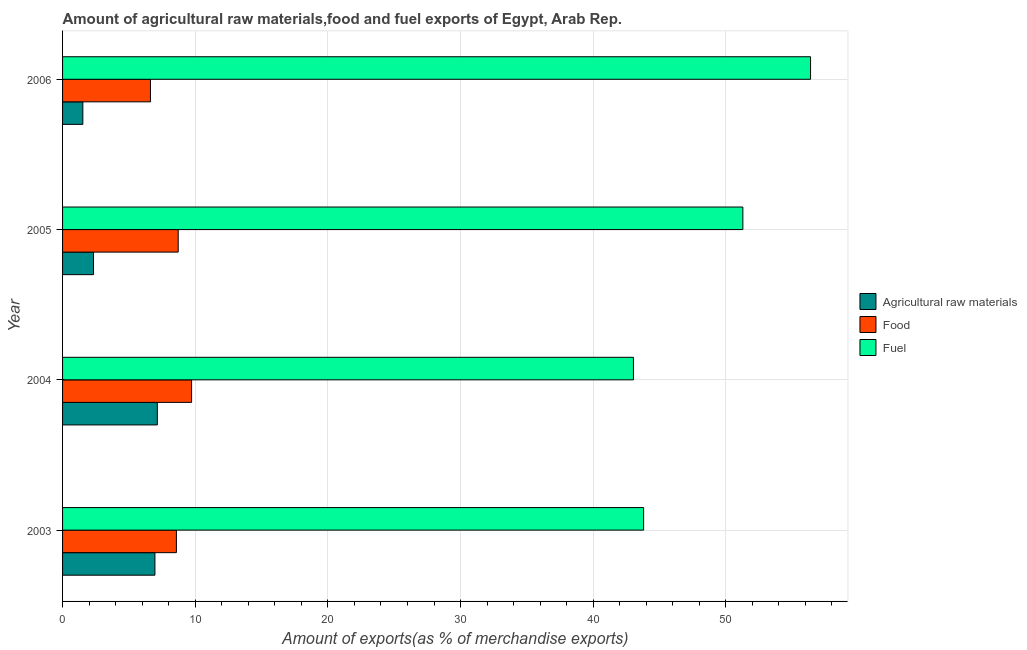How many different coloured bars are there?
Your answer should be compact. 3. Are the number of bars per tick equal to the number of legend labels?
Ensure brevity in your answer.  Yes. Are the number of bars on each tick of the Y-axis equal?
Give a very brief answer. Yes. What is the label of the 4th group of bars from the top?
Your answer should be very brief. 2003. What is the percentage of food exports in 2006?
Offer a very short reply. 6.63. Across all years, what is the maximum percentage of fuel exports?
Give a very brief answer. 56.39. Across all years, what is the minimum percentage of fuel exports?
Ensure brevity in your answer.  43.03. In which year was the percentage of raw materials exports maximum?
Keep it short and to the point. 2004. What is the total percentage of food exports in the graph?
Keep it short and to the point. 33.65. What is the difference between the percentage of fuel exports in 2004 and that in 2005?
Provide a short and direct response. -8.25. What is the difference between the percentage of food exports in 2004 and the percentage of fuel exports in 2005?
Your answer should be compact. -41.56. What is the average percentage of raw materials exports per year?
Your answer should be very brief. 4.49. In the year 2005, what is the difference between the percentage of raw materials exports and percentage of food exports?
Make the answer very short. -6.39. What is the ratio of the percentage of fuel exports in 2003 to that in 2005?
Provide a short and direct response. 0.85. Is the difference between the percentage of fuel exports in 2005 and 2006 greater than the difference between the percentage of food exports in 2005 and 2006?
Your answer should be compact. No. What is the difference between the highest and the second highest percentage of raw materials exports?
Give a very brief answer. 0.18. What is the difference between the highest and the lowest percentage of raw materials exports?
Give a very brief answer. 5.62. In how many years, is the percentage of fuel exports greater than the average percentage of fuel exports taken over all years?
Provide a short and direct response. 2. What does the 2nd bar from the top in 2005 represents?
Provide a succinct answer. Food. What does the 2nd bar from the bottom in 2006 represents?
Keep it short and to the point. Food. Is it the case that in every year, the sum of the percentage of raw materials exports and percentage of food exports is greater than the percentage of fuel exports?
Provide a short and direct response. No. How many bars are there?
Provide a short and direct response. 12. What is the difference between two consecutive major ticks on the X-axis?
Your response must be concise. 10. Where does the legend appear in the graph?
Offer a very short reply. Center right. How are the legend labels stacked?
Keep it short and to the point. Vertical. What is the title of the graph?
Offer a terse response. Amount of agricultural raw materials,food and fuel exports of Egypt, Arab Rep. Does "Male employers" appear as one of the legend labels in the graph?
Make the answer very short. No. What is the label or title of the X-axis?
Your response must be concise. Amount of exports(as % of merchandise exports). What is the label or title of the Y-axis?
Provide a short and direct response. Year. What is the Amount of exports(as % of merchandise exports) of Agricultural raw materials in 2003?
Provide a short and direct response. 6.96. What is the Amount of exports(as % of merchandise exports) in Food in 2003?
Offer a terse response. 8.58. What is the Amount of exports(as % of merchandise exports) in Fuel in 2003?
Offer a very short reply. 43.8. What is the Amount of exports(as % of merchandise exports) in Agricultural raw materials in 2004?
Provide a short and direct response. 7.14. What is the Amount of exports(as % of merchandise exports) of Food in 2004?
Your answer should be compact. 9.73. What is the Amount of exports(as % of merchandise exports) of Fuel in 2004?
Provide a succinct answer. 43.03. What is the Amount of exports(as % of merchandise exports) of Agricultural raw materials in 2005?
Provide a short and direct response. 2.33. What is the Amount of exports(as % of merchandise exports) of Food in 2005?
Ensure brevity in your answer.  8.72. What is the Amount of exports(as % of merchandise exports) in Fuel in 2005?
Ensure brevity in your answer.  51.28. What is the Amount of exports(as % of merchandise exports) in Agricultural raw materials in 2006?
Your answer should be very brief. 1.53. What is the Amount of exports(as % of merchandise exports) of Food in 2006?
Provide a succinct answer. 6.63. What is the Amount of exports(as % of merchandise exports) of Fuel in 2006?
Give a very brief answer. 56.39. Across all years, what is the maximum Amount of exports(as % of merchandise exports) in Agricultural raw materials?
Your answer should be very brief. 7.14. Across all years, what is the maximum Amount of exports(as % of merchandise exports) of Food?
Your answer should be very brief. 9.73. Across all years, what is the maximum Amount of exports(as % of merchandise exports) of Fuel?
Give a very brief answer. 56.39. Across all years, what is the minimum Amount of exports(as % of merchandise exports) of Agricultural raw materials?
Offer a very short reply. 1.53. Across all years, what is the minimum Amount of exports(as % of merchandise exports) in Food?
Make the answer very short. 6.63. Across all years, what is the minimum Amount of exports(as % of merchandise exports) of Fuel?
Give a very brief answer. 43.03. What is the total Amount of exports(as % of merchandise exports) of Agricultural raw materials in the graph?
Give a very brief answer. 17.97. What is the total Amount of exports(as % of merchandise exports) in Food in the graph?
Keep it short and to the point. 33.65. What is the total Amount of exports(as % of merchandise exports) of Fuel in the graph?
Provide a short and direct response. 194.51. What is the difference between the Amount of exports(as % of merchandise exports) in Agricultural raw materials in 2003 and that in 2004?
Offer a terse response. -0.18. What is the difference between the Amount of exports(as % of merchandise exports) of Food in 2003 and that in 2004?
Offer a very short reply. -1.14. What is the difference between the Amount of exports(as % of merchandise exports) of Fuel in 2003 and that in 2004?
Ensure brevity in your answer.  0.77. What is the difference between the Amount of exports(as % of merchandise exports) of Agricultural raw materials in 2003 and that in 2005?
Provide a succinct answer. 4.63. What is the difference between the Amount of exports(as % of merchandise exports) of Food in 2003 and that in 2005?
Your answer should be very brief. -0.14. What is the difference between the Amount of exports(as % of merchandise exports) of Fuel in 2003 and that in 2005?
Make the answer very short. -7.48. What is the difference between the Amount of exports(as % of merchandise exports) of Agricultural raw materials in 2003 and that in 2006?
Give a very brief answer. 5.43. What is the difference between the Amount of exports(as % of merchandise exports) of Food in 2003 and that in 2006?
Provide a succinct answer. 1.96. What is the difference between the Amount of exports(as % of merchandise exports) in Fuel in 2003 and that in 2006?
Offer a terse response. -12.58. What is the difference between the Amount of exports(as % of merchandise exports) in Agricultural raw materials in 2004 and that in 2005?
Offer a very short reply. 4.81. What is the difference between the Amount of exports(as % of merchandise exports) in Food in 2004 and that in 2005?
Provide a succinct answer. 1.01. What is the difference between the Amount of exports(as % of merchandise exports) of Fuel in 2004 and that in 2005?
Your response must be concise. -8.25. What is the difference between the Amount of exports(as % of merchandise exports) of Agricultural raw materials in 2004 and that in 2006?
Your answer should be very brief. 5.62. What is the difference between the Amount of exports(as % of merchandise exports) in Food in 2004 and that in 2006?
Keep it short and to the point. 3.1. What is the difference between the Amount of exports(as % of merchandise exports) in Fuel in 2004 and that in 2006?
Your answer should be compact. -13.35. What is the difference between the Amount of exports(as % of merchandise exports) of Agricultural raw materials in 2005 and that in 2006?
Your answer should be very brief. 0.8. What is the difference between the Amount of exports(as % of merchandise exports) of Food in 2005 and that in 2006?
Offer a very short reply. 2.09. What is the difference between the Amount of exports(as % of merchandise exports) of Fuel in 2005 and that in 2006?
Offer a very short reply. -5.1. What is the difference between the Amount of exports(as % of merchandise exports) of Agricultural raw materials in 2003 and the Amount of exports(as % of merchandise exports) of Food in 2004?
Offer a terse response. -2.76. What is the difference between the Amount of exports(as % of merchandise exports) of Agricultural raw materials in 2003 and the Amount of exports(as % of merchandise exports) of Fuel in 2004?
Your answer should be compact. -36.07. What is the difference between the Amount of exports(as % of merchandise exports) of Food in 2003 and the Amount of exports(as % of merchandise exports) of Fuel in 2004?
Your response must be concise. -34.45. What is the difference between the Amount of exports(as % of merchandise exports) in Agricultural raw materials in 2003 and the Amount of exports(as % of merchandise exports) in Food in 2005?
Give a very brief answer. -1.76. What is the difference between the Amount of exports(as % of merchandise exports) of Agricultural raw materials in 2003 and the Amount of exports(as % of merchandise exports) of Fuel in 2005?
Offer a terse response. -44.32. What is the difference between the Amount of exports(as % of merchandise exports) in Food in 2003 and the Amount of exports(as % of merchandise exports) in Fuel in 2005?
Your answer should be very brief. -42.7. What is the difference between the Amount of exports(as % of merchandise exports) in Agricultural raw materials in 2003 and the Amount of exports(as % of merchandise exports) in Food in 2006?
Keep it short and to the point. 0.34. What is the difference between the Amount of exports(as % of merchandise exports) of Agricultural raw materials in 2003 and the Amount of exports(as % of merchandise exports) of Fuel in 2006?
Ensure brevity in your answer.  -49.42. What is the difference between the Amount of exports(as % of merchandise exports) of Food in 2003 and the Amount of exports(as % of merchandise exports) of Fuel in 2006?
Provide a short and direct response. -47.8. What is the difference between the Amount of exports(as % of merchandise exports) in Agricultural raw materials in 2004 and the Amount of exports(as % of merchandise exports) in Food in 2005?
Ensure brevity in your answer.  -1.57. What is the difference between the Amount of exports(as % of merchandise exports) in Agricultural raw materials in 2004 and the Amount of exports(as % of merchandise exports) in Fuel in 2005?
Offer a terse response. -44.14. What is the difference between the Amount of exports(as % of merchandise exports) in Food in 2004 and the Amount of exports(as % of merchandise exports) in Fuel in 2005?
Offer a terse response. -41.56. What is the difference between the Amount of exports(as % of merchandise exports) of Agricultural raw materials in 2004 and the Amount of exports(as % of merchandise exports) of Food in 2006?
Your response must be concise. 0.52. What is the difference between the Amount of exports(as % of merchandise exports) of Agricultural raw materials in 2004 and the Amount of exports(as % of merchandise exports) of Fuel in 2006?
Give a very brief answer. -49.24. What is the difference between the Amount of exports(as % of merchandise exports) of Food in 2004 and the Amount of exports(as % of merchandise exports) of Fuel in 2006?
Provide a succinct answer. -46.66. What is the difference between the Amount of exports(as % of merchandise exports) of Agricultural raw materials in 2005 and the Amount of exports(as % of merchandise exports) of Food in 2006?
Make the answer very short. -4.29. What is the difference between the Amount of exports(as % of merchandise exports) of Agricultural raw materials in 2005 and the Amount of exports(as % of merchandise exports) of Fuel in 2006?
Your response must be concise. -54.05. What is the difference between the Amount of exports(as % of merchandise exports) of Food in 2005 and the Amount of exports(as % of merchandise exports) of Fuel in 2006?
Your answer should be very brief. -47.67. What is the average Amount of exports(as % of merchandise exports) of Agricultural raw materials per year?
Ensure brevity in your answer.  4.49. What is the average Amount of exports(as % of merchandise exports) in Food per year?
Your answer should be very brief. 8.41. What is the average Amount of exports(as % of merchandise exports) of Fuel per year?
Offer a terse response. 48.63. In the year 2003, what is the difference between the Amount of exports(as % of merchandise exports) of Agricultural raw materials and Amount of exports(as % of merchandise exports) of Food?
Offer a very short reply. -1.62. In the year 2003, what is the difference between the Amount of exports(as % of merchandise exports) in Agricultural raw materials and Amount of exports(as % of merchandise exports) in Fuel?
Your answer should be very brief. -36.84. In the year 2003, what is the difference between the Amount of exports(as % of merchandise exports) of Food and Amount of exports(as % of merchandise exports) of Fuel?
Ensure brevity in your answer.  -35.22. In the year 2004, what is the difference between the Amount of exports(as % of merchandise exports) in Agricultural raw materials and Amount of exports(as % of merchandise exports) in Food?
Provide a short and direct response. -2.58. In the year 2004, what is the difference between the Amount of exports(as % of merchandise exports) of Agricultural raw materials and Amount of exports(as % of merchandise exports) of Fuel?
Your answer should be compact. -35.89. In the year 2004, what is the difference between the Amount of exports(as % of merchandise exports) of Food and Amount of exports(as % of merchandise exports) of Fuel?
Offer a very short reply. -33.31. In the year 2005, what is the difference between the Amount of exports(as % of merchandise exports) in Agricultural raw materials and Amount of exports(as % of merchandise exports) in Food?
Give a very brief answer. -6.39. In the year 2005, what is the difference between the Amount of exports(as % of merchandise exports) of Agricultural raw materials and Amount of exports(as % of merchandise exports) of Fuel?
Your answer should be compact. -48.95. In the year 2005, what is the difference between the Amount of exports(as % of merchandise exports) of Food and Amount of exports(as % of merchandise exports) of Fuel?
Your answer should be very brief. -42.57. In the year 2006, what is the difference between the Amount of exports(as % of merchandise exports) of Agricultural raw materials and Amount of exports(as % of merchandise exports) of Food?
Make the answer very short. -5.1. In the year 2006, what is the difference between the Amount of exports(as % of merchandise exports) of Agricultural raw materials and Amount of exports(as % of merchandise exports) of Fuel?
Make the answer very short. -54.86. In the year 2006, what is the difference between the Amount of exports(as % of merchandise exports) in Food and Amount of exports(as % of merchandise exports) in Fuel?
Keep it short and to the point. -49.76. What is the ratio of the Amount of exports(as % of merchandise exports) in Agricultural raw materials in 2003 to that in 2004?
Offer a very short reply. 0.97. What is the ratio of the Amount of exports(as % of merchandise exports) of Food in 2003 to that in 2004?
Make the answer very short. 0.88. What is the ratio of the Amount of exports(as % of merchandise exports) in Fuel in 2003 to that in 2004?
Your response must be concise. 1.02. What is the ratio of the Amount of exports(as % of merchandise exports) of Agricultural raw materials in 2003 to that in 2005?
Offer a terse response. 2.99. What is the ratio of the Amount of exports(as % of merchandise exports) in Food in 2003 to that in 2005?
Provide a succinct answer. 0.98. What is the ratio of the Amount of exports(as % of merchandise exports) of Fuel in 2003 to that in 2005?
Offer a very short reply. 0.85. What is the ratio of the Amount of exports(as % of merchandise exports) in Agricultural raw materials in 2003 to that in 2006?
Offer a terse response. 4.55. What is the ratio of the Amount of exports(as % of merchandise exports) in Food in 2003 to that in 2006?
Provide a succinct answer. 1.3. What is the ratio of the Amount of exports(as % of merchandise exports) in Fuel in 2003 to that in 2006?
Give a very brief answer. 0.78. What is the ratio of the Amount of exports(as % of merchandise exports) of Agricultural raw materials in 2004 to that in 2005?
Provide a succinct answer. 3.06. What is the ratio of the Amount of exports(as % of merchandise exports) of Food in 2004 to that in 2005?
Ensure brevity in your answer.  1.12. What is the ratio of the Amount of exports(as % of merchandise exports) in Fuel in 2004 to that in 2005?
Make the answer very short. 0.84. What is the ratio of the Amount of exports(as % of merchandise exports) of Agricultural raw materials in 2004 to that in 2006?
Give a very brief answer. 4.67. What is the ratio of the Amount of exports(as % of merchandise exports) of Food in 2004 to that in 2006?
Make the answer very short. 1.47. What is the ratio of the Amount of exports(as % of merchandise exports) of Fuel in 2004 to that in 2006?
Offer a terse response. 0.76. What is the ratio of the Amount of exports(as % of merchandise exports) of Agricultural raw materials in 2005 to that in 2006?
Offer a very short reply. 1.53. What is the ratio of the Amount of exports(as % of merchandise exports) of Food in 2005 to that in 2006?
Make the answer very short. 1.32. What is the ratio of the Amount of exports(as % of merchandise exports) of Fuel in 2005 to that in 2006?
Provide a succinct answer. 0.91. What is the difference between the highest and the second highest Amount of exports(as % of merchandise exports) in Agricultural raw materials?
Give a very brief answer. 0.18. What is the difference between the highest and the second highest Amount of exports(as % of merchandise exports) of Food?
Ensure brevity in your answer.  1.01. What is the difference between the highest and the second highest Amount of exports(as % of merchandise exports) of Fuel?
Ensure brevity in your answer.  5.1. What is the difference between the highest and the lowest Amount of exports(as % of merchandise exports) of Agricultural raw materials?
Offer a very short reply. 5.62. What is the difference between the highest and the lowest Amount of exports(as % of merchandise exports) of Food?
Your answer should be compact. 3.1. What is the difference between the highest and the lowest Amount of exports(as % of merchandise exports) of Fuel?
Provide a short and direct response. 13.35. 